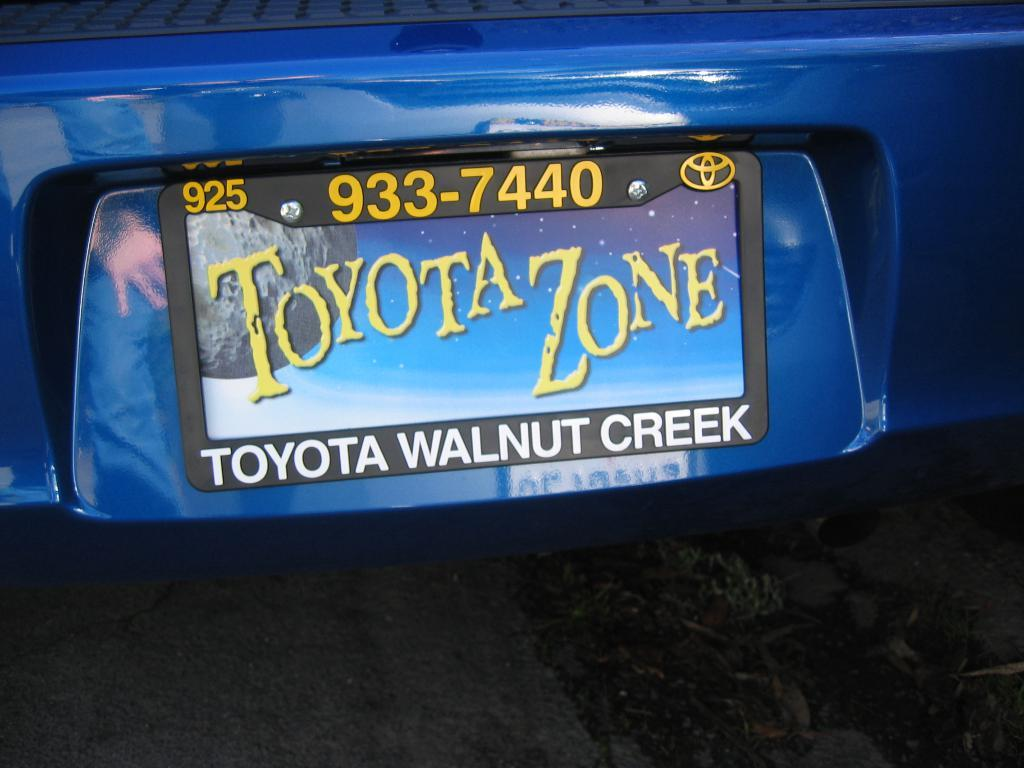<image>
Write a terse but informative summary of the picture. A licence plate in shown on a blue car with Toyota on the plate. 